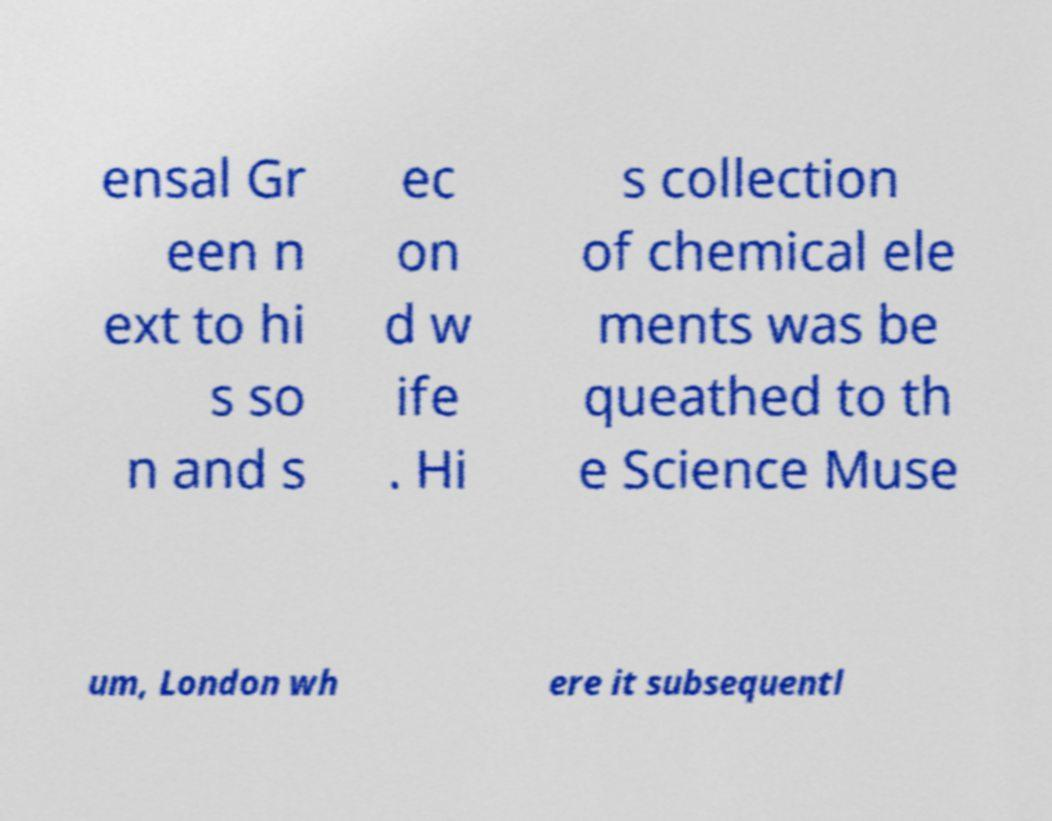Please identify and transcribe the text found in this image. ensal Gr een n ext to hi s so n and s ec on d w ife . Hi s collection of chemical ele ments was be queathed to th e Science Muse um, London wh ere it subsequentl 